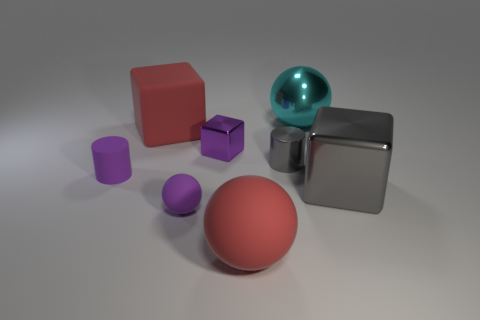There is a small cylinder that is to the right of the large red matte sphere that is right of the tiny cube that is in front of the metallic ball; what is it made of?
Offer a very short reply. Metal. Is the material of the cylinder on the right side of the small purple block the same as the cyan thing?
Offer a terse response. Yes. What number of purple things are the same size as the shiny cylinder?
Your answer should be very brief. 3. Is the number of cyan balls on the right side of the small gray metallic thing greater than the number of rubber spheres behind the gray cube?
Give a very brief answer. Yes. Are there any small purple matte objects that have the same shape as the big cyan object?
Your answer should be compact. Yes. What is the size of the cylinder that is left of the red thing behind the gray metallic cube?
Ensure brevity in your answer.  Small. There is a large red rubber thing behind the metallic block to the right of the big red ball that is in front of the big cyan metal object; what is its shape?
Provide a short and direct response. Cube. What size is the purple cylinder that is made of the same material as the large red sphere?
Your answer should be very brief. Small. Are there more purple cubes than gray shiny balls?
Give a very brief answer. Yes. What material is the gray cube that is the same size as the red rubber ball?
Keep it short and to the point. Metal. 